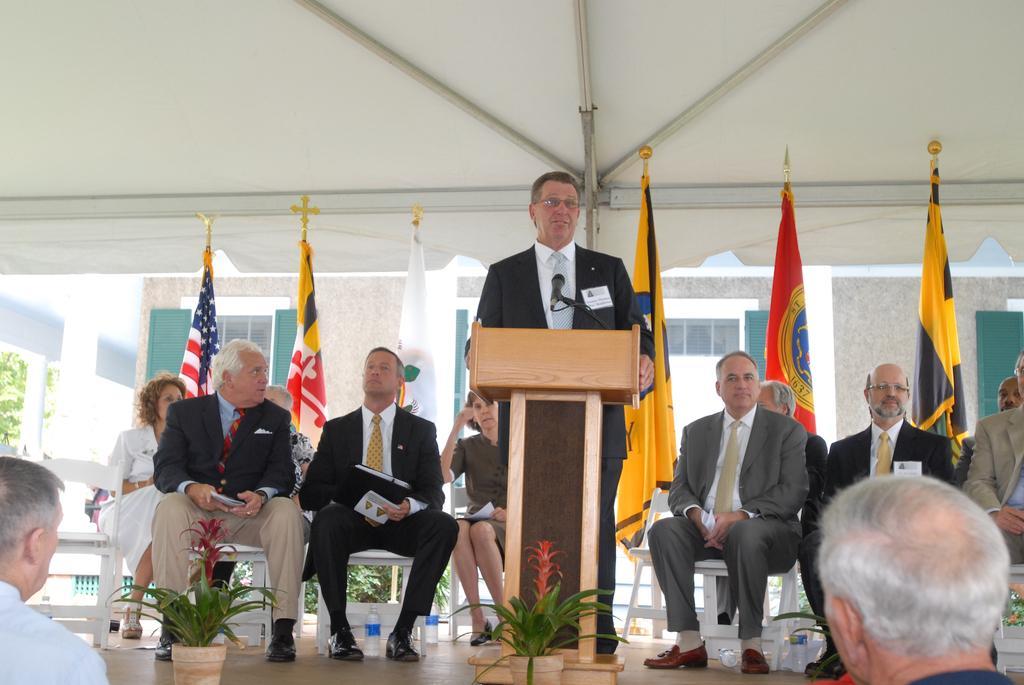Can you describe this image briefly? The man in the middle of the picture wearing black blazer is standing. In front of him, we see a podium on which the microphone is placed. He is talking on the microphone. Behind him, we see many people are sitting on the chairs and most of them are holding the papers and books in their hands. At the bottom, we see two men and flower pots. We even see water bottles. Behind them, we see flags in white, red, yellow, blue and black color. Behind them, we see the buildings. 